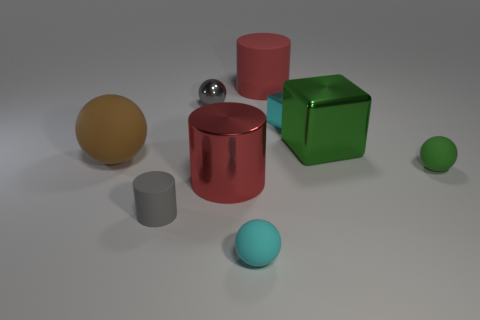Is the gray rubber object the same size as the metal ball?
Provide a short and direct response. Yes. There is another red object that is the same shape as the big red metal object; what material is it?
Keep it short and to the point. Rubber. Is there any other thing that has the same material as the tiny cylinder?
Your answer should be very brief. Yes. How many red things are small balls or metallic cylinders?
Ensure brevity in your answer.  1. What is the material of the large red cylinder that is in front of the big green block?
Give a very brief answer. Metal. Are there more cylinders than red matte cylinders?
Offer a terse response. Yes. There is a rubber object that is on the right side of the large red rubber thing; does it have the same shape as the cyan matte thing?
Your answer should be compact. Yes. What number of tiny objects are left of the tiny cyan rubber ball and behind the large matte sphere?
Your response must be concise. 1. How many gray rubber things are the same shape as the green metal thing?
Provide a short and direct response. 0. There is a tiny shiny thing that is on the right side of the small ball behind the big brown thing; what is its color?
Ensure brevity in your answer.  Cyan. 